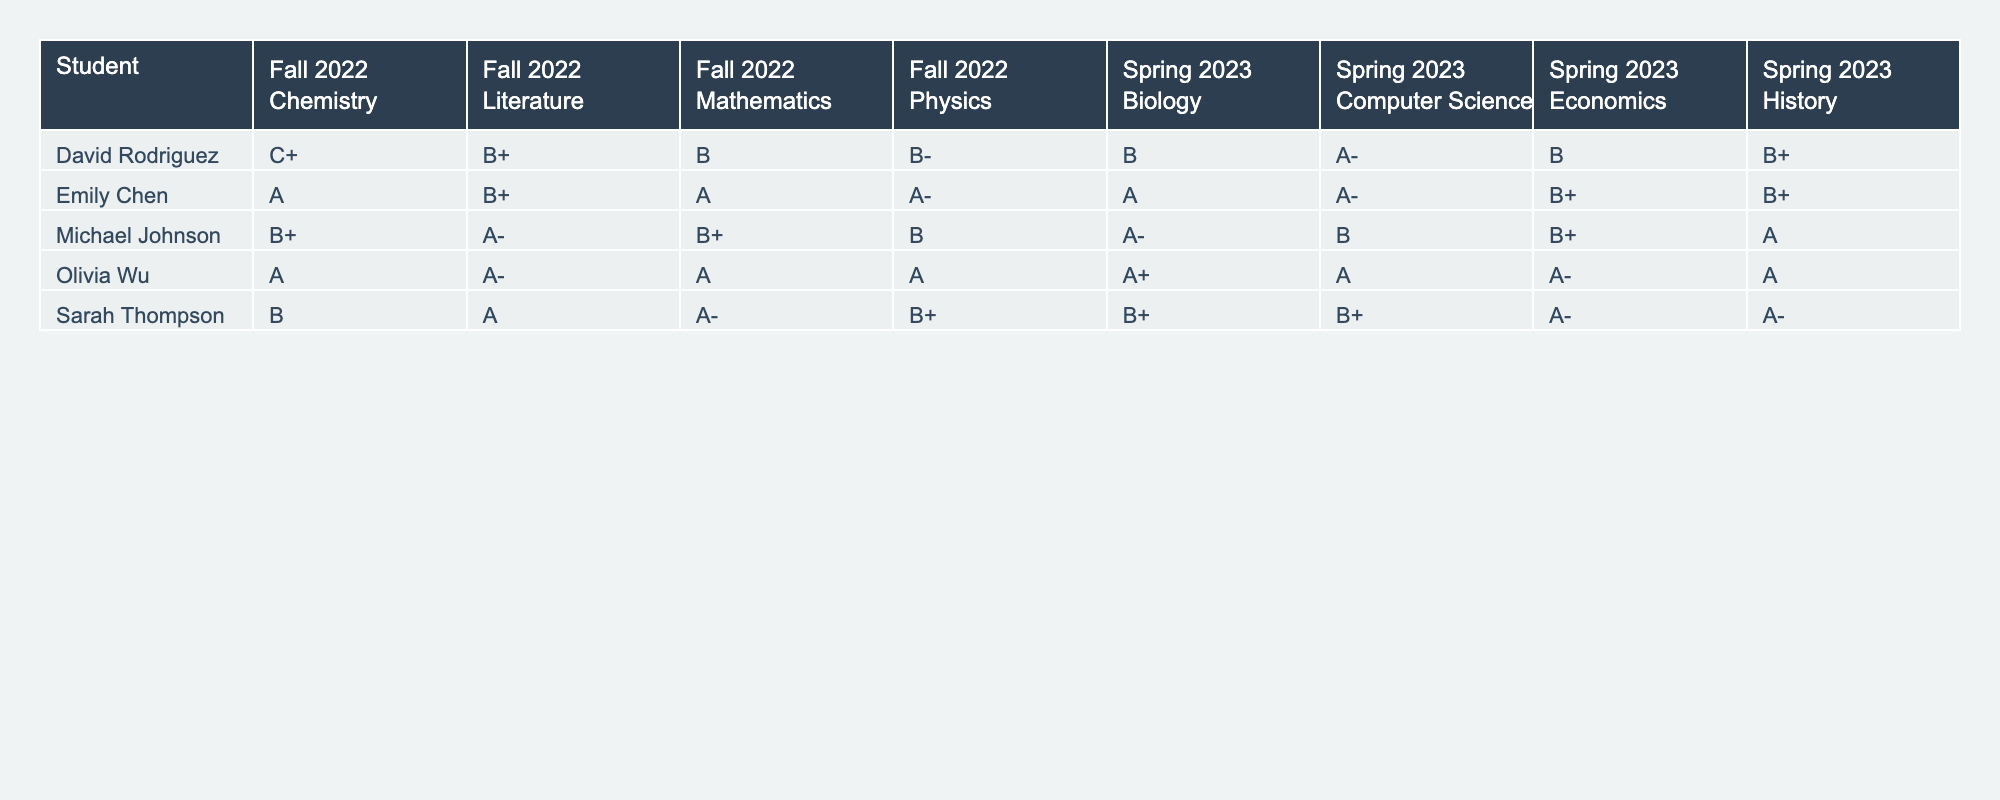What grade did Emily Chen receive in Literature for Fall 2022? From the table, I found Emily Chen's grades in Literature during Fall 2022, which is listed under the corresponding cell. It shows a grade of B+.
Answer: B+ What is the highest grade obtained in Biology across all students in Spring 2023? Looking at the Spring 2023 semester for Biology, I'll compare the grades across all students. Olivia Wu earned an A+, which is the highest of the grades listed for that subject.
Answer: A+ Did Michael Johnson improve his grade in Computer Science from Fall 2022 to Spring 2023? In Fall 2022, Michael Johnson received a grade of B in Computer Science. In Spring 2023, he received a grade of B. Since both grades are the same, there is no improvement.
Answer: No What is the average grade in Physics for all students in Fall 2022? The grades for Physics in Fall 2022 are A, B, B+, A, and A. First, I convert these letter grades to a numeric scale: A=4, A-=3.7, B+=3.3, B=3, B-=2.7. The values become 4, 3.7, 3.3, 4, and 4. Therefore, the sum is 18.0 and dividing by the number of grades (5), the average is 18.0/5 = 3.6.
Answer: 3.6 Which student had the most consistent grades across both semesters? To determine consistency, I will look at the grades for each student from Fall 2022 to Spring 2023. Consistency is indicated by similar grades across semesters. After reviewing each student's data, Emily Chen had an A average with grades of A and A- in different subjects, showing less variability.
Answer: Emily Chen What is the difference between the highest and lowest grades received by David Rodriguez in Spring 2023? Examining David Rodriguez's Spring 2023 grades, he received B for Biology, B+ for History, A- for Computer Science, and B for Economics. The highest grade is A- (equivalent to 3.7) and the lowest grade is B (equivalent to 3.0). To find the difference, I calculate 3.7 - 3.0 = 0.7.
Answer: 0.7 Did any students receive the same grade in Economics for Spring 2023? In the Economics subject for Spring 2023, I will check if any students share the same grade. The grades are B+, A-, and A, and observing these, I can confirm that David Rodriguez and Michael Johnson both received B+.
Answer: Yes What grade did Olivia Wu achieve in History and how does it compare to her grade in the same subject for Fall 2022? In Spring 2023, Olivia Wu received an A in History, while, reviewing Fall 2022, I find that she did not take History. Therefore, I can only mention the grade for Spring 2023 and state that there is no comparison available.
Answer: A, cannot compare 